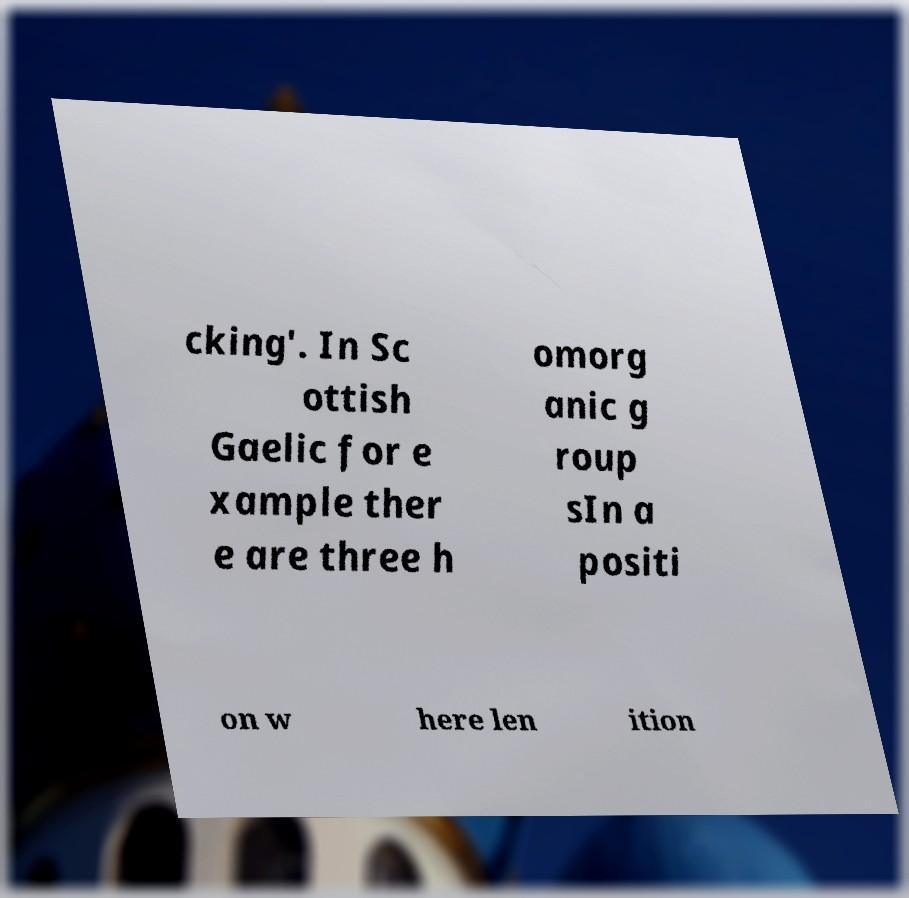Could you assist in decoding the text presented in this image and type it out clearly? cking'. In Sc ottish Gaelic for e xample ther e are three h omorg anic g roup sIn a positi on w here len ition 